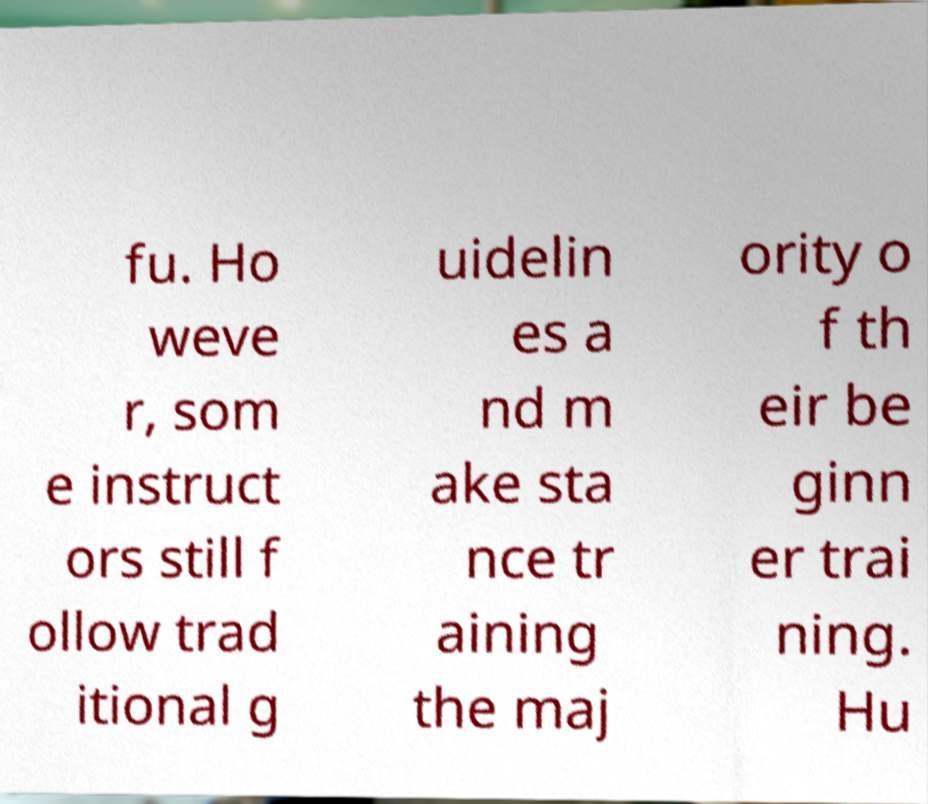Please read and relay the text visible in this image. What does it say? fu. Ho weve r, som e instruct ors still f ollow trad itional g uidelin es a nd m ake sta nce tr aining the maj ority o f th eir be ginn er trai ning. Hu 